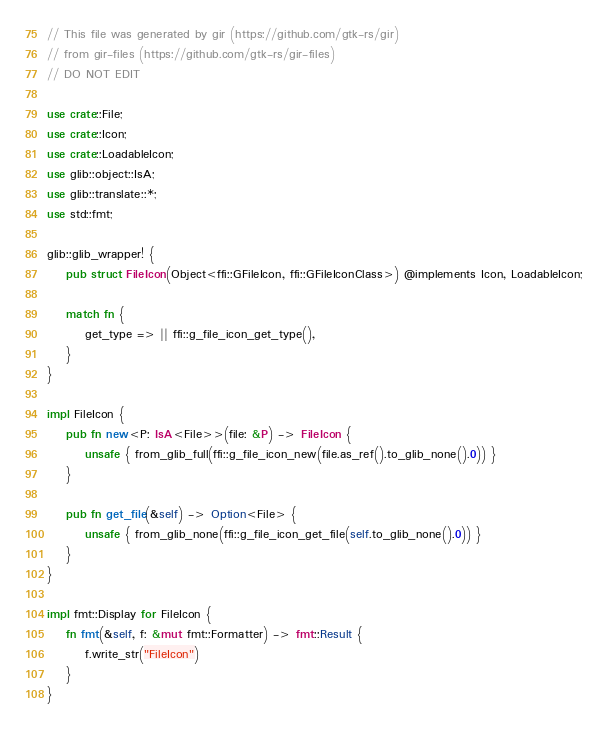<code> <loc_0><loc_0><loc_500><loc_500><_Rust_>// This file was generated by gir (https://github.com/gtk-rs/gir)
// from gir-files (https://github.com/gtk-rs/gir-files)
// DO NOT EDIT

use crate::File;
use crate::Icon;
use crate::LoadableIcon;
use glib::object::IsA;
use glib::translate::*;
use std::fmt;

glib::glib_wrapper! {
    pub struct FileIcon(Object<ffi::GFileIcon, ffi::GFileIconClass>) @implements Icon, LoadableIcon;

    match fn {
        get_type => || ffi::g_file_icon_get_type(),
    }
}

impl FileIcon {
    pub fn new<P: IsA<File>>(file: &P) -> FileIcon {
        unsafe { from_glib_full(ffi::g_file_icon_new(file.as_ref().to_glib_none().0)) }
    }

    pub fn get_file(&self) -> Option<File> {
        unsafe { from_glib_none(ffi::g_file_icon_get_file(self.to_glib_none().0)) }
    }
}

impl fmt::Display for FileIcon {
    fn fmt(&self, f: &mut fmt::Formatter) -> fmt::Result {
        f.write_str("FileIcon")
    }
}
</code> 